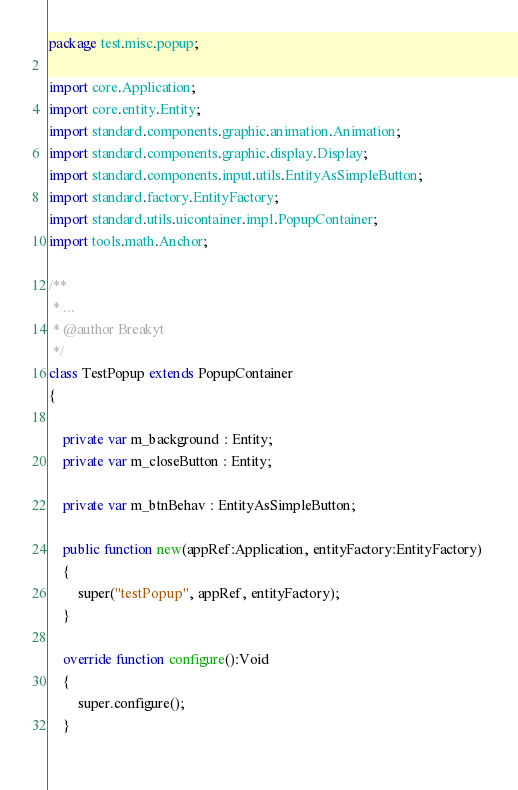Convert code to text. <code><loc_0><loc_0><loc_500><loc_500><_Haxe_>package test.misc.popup;

import core.Application;
import core.entity.Entity;
import standard.components.graphic.animation.Animation;
import standard.components.graphic.display.Display;
import standard.components.input.utils.EntityAsSimpleButton;
import standard.factory.EntityFactory;
import standard.utils.uicontainer.impl.PopupContainer;
import tools.math.Anchor;

/**
 * ...
 * @author Breakyt
 */
class TestPopup extends PopupContainer 
{

	private var m_background : Entity;
	private var m_closeButton : Entity;
	
	private var m_btnBehav : EntityAsSimpleButton;
	
	public function new(appRef:Application, entityFactory:EntityFactory) 
	{
		super("testPopup", appRef, entityFactory);
	}
	
	override function configure():Void 
	{
		super.configure();
	}
	</code> 